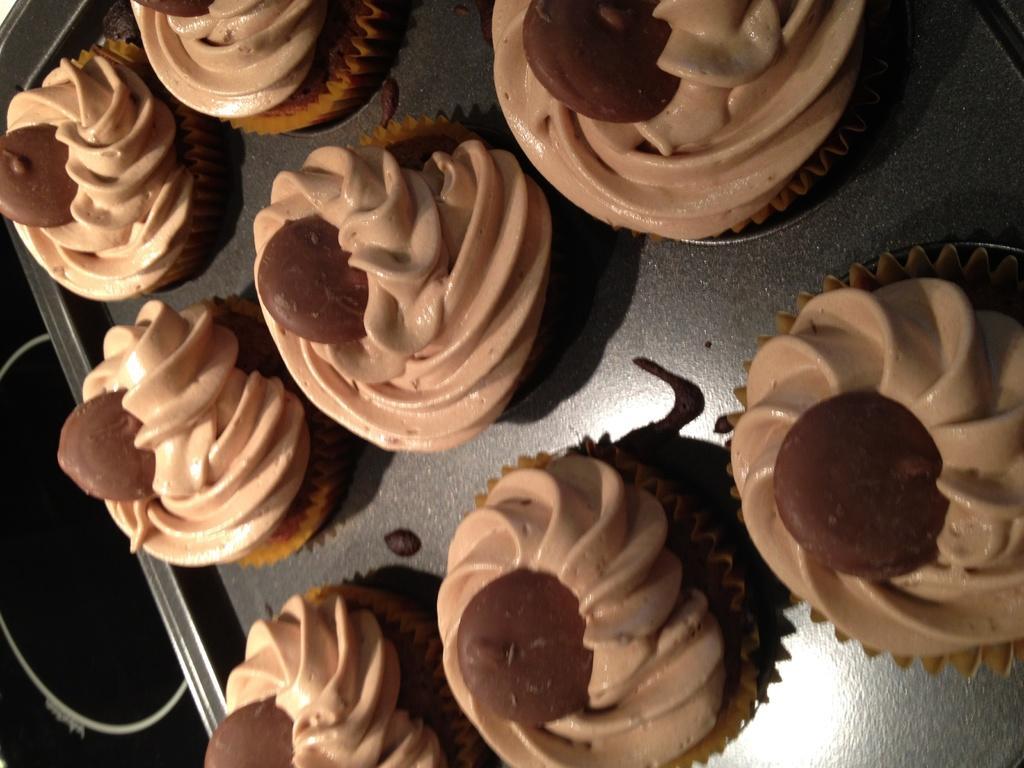Please provide a concise description of this image. In this picture we can see cupcakes on a tray and in the background we can see an object. 